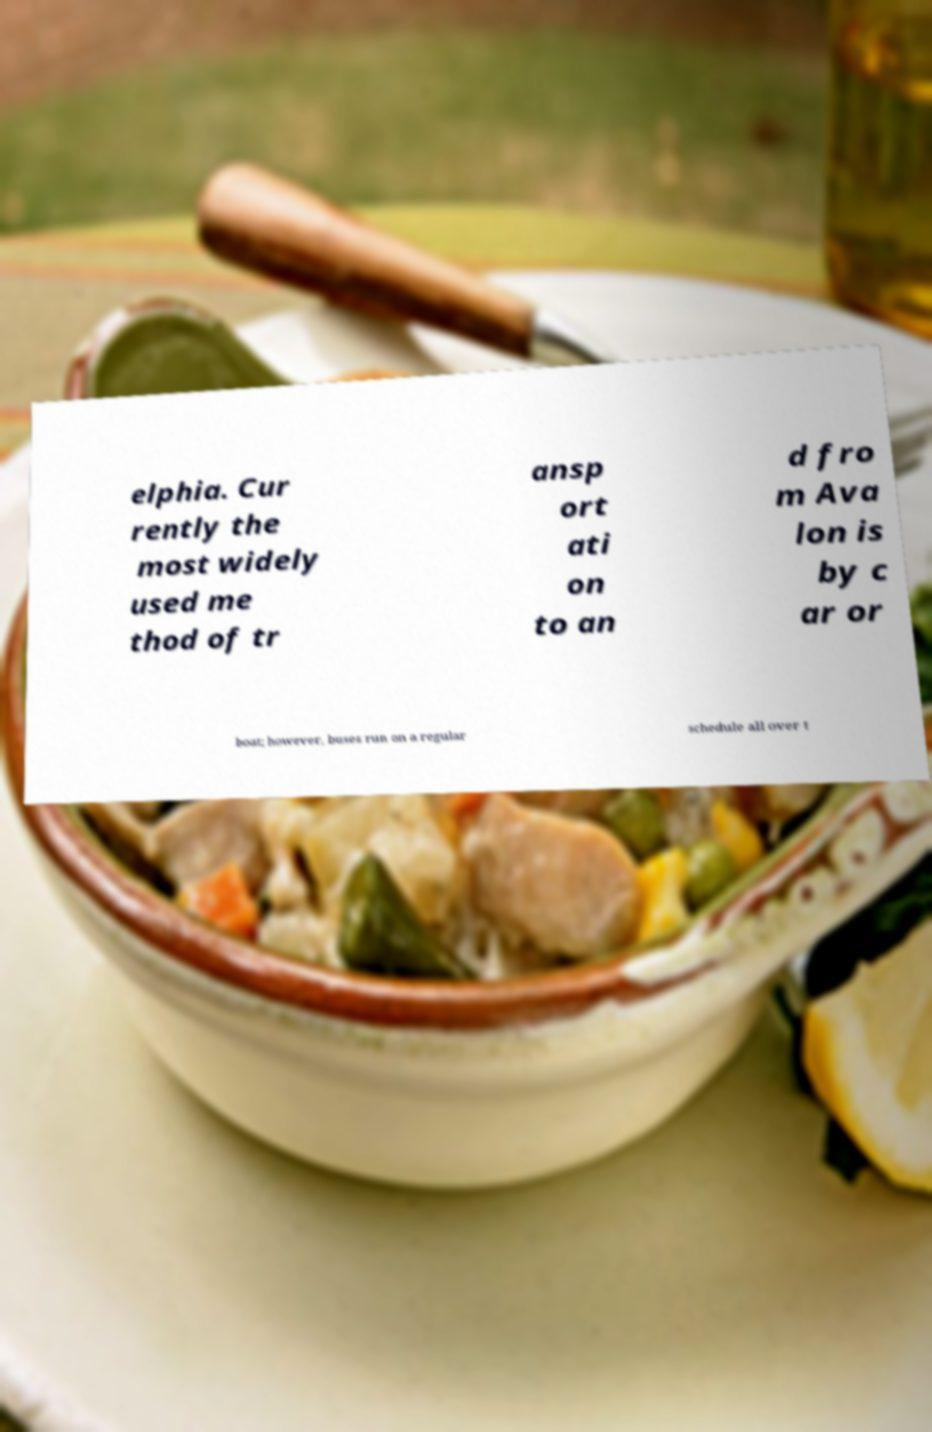Can you read and provide the text displayed in the image?This photo seems to have some interesting text. Can you extract and type it out for me? elphia. Cur rently the most widely used me thod of tr ansp ort ati on to an d fro m Ava lon is by c ar or boat; however, buses run on a regular schedule all over t 